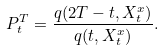Convert formula to latex. <formula><loc_0><loc_0><loc_500><loc_500>P _ { t } ^ { T } = \frac { q ( 2 T - t , X ^ { x } _ { t } ) } { q ( t , X ^ { x } _ { t } ) } .</formula> 